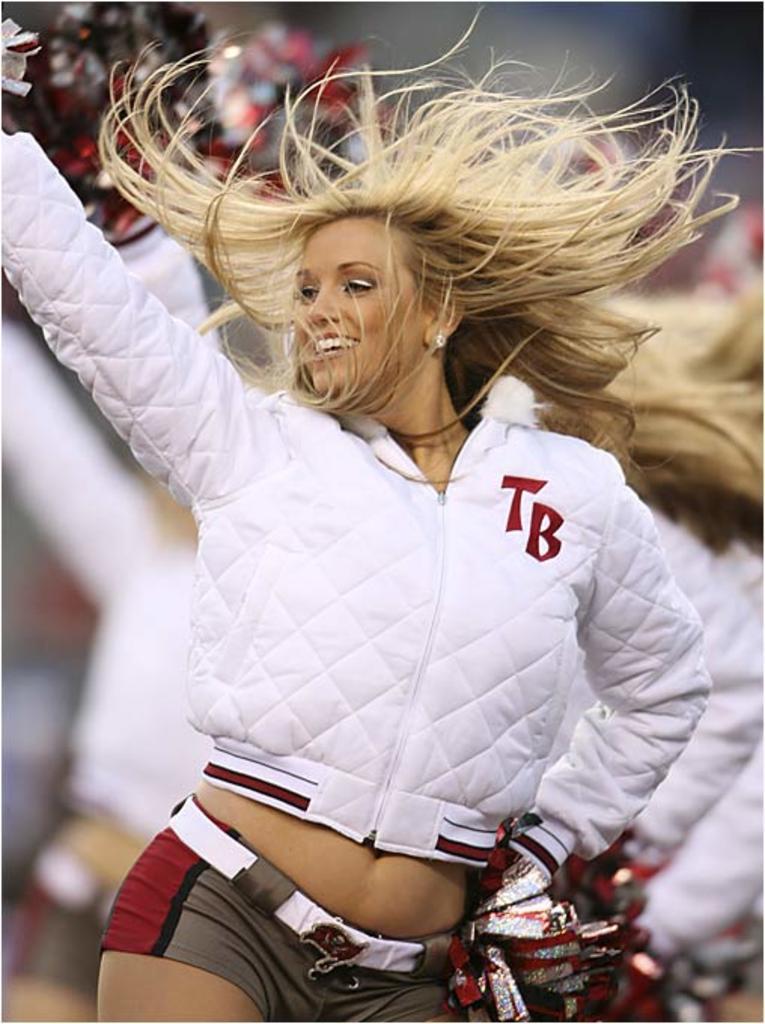Please provide a concise description of this image. In this image we can see a lady person wearing white color jacket and brown color short also wearing gloves dancing.` 